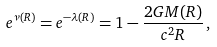Convert formula to latex. <formula><loc_0><loc_0><loc_500><loc_500>e ^ { \nu ( R ) } = e ^ { - \lambda ( R ) } = 1 - \frac { 2 G M ( R ) } { c ^ { 2 } R } \, ,</formula> 